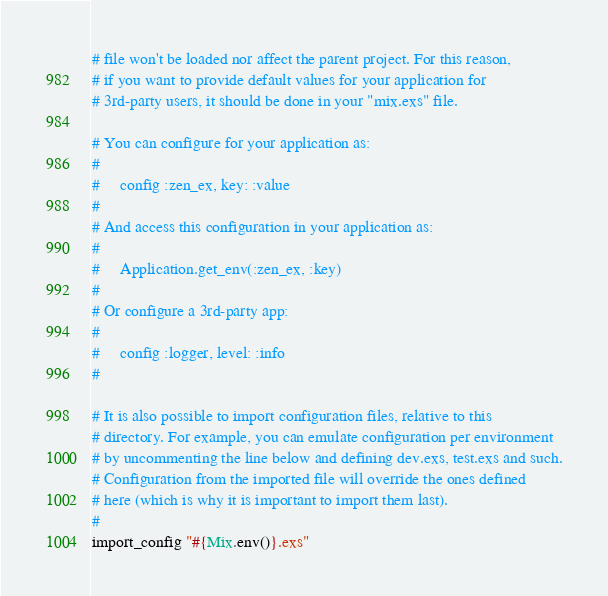<code> <loc_0><loc_0><loc_500><loc_500><_Elixir_># file won't be loaded nor affect the parent project. For this reason,
# if you want to provide default values for your application for
# 3rd-party users, it should be done in your "mix.exs" file.

# You can configure for your application as:
#
#     config :zen_ex, key: :value
#
# And access this configuration in your application as:
#
#     Application.get_env(:zen_ex, :key)
#
# Or configure a 3rd-party app:
#
#     config :logger, level: :info
#

# It is also possible to import configuration files, relative to this
# directory. For example, you can emulate configuration per environment
# by uncommenting the line below and defining dev.exs, test.exs and such.
# Configuration from the imported file will override the ones defined
# here (which is why it is important to import them last).
#
import_config "#{Mix.env()}.exs"
</code> 